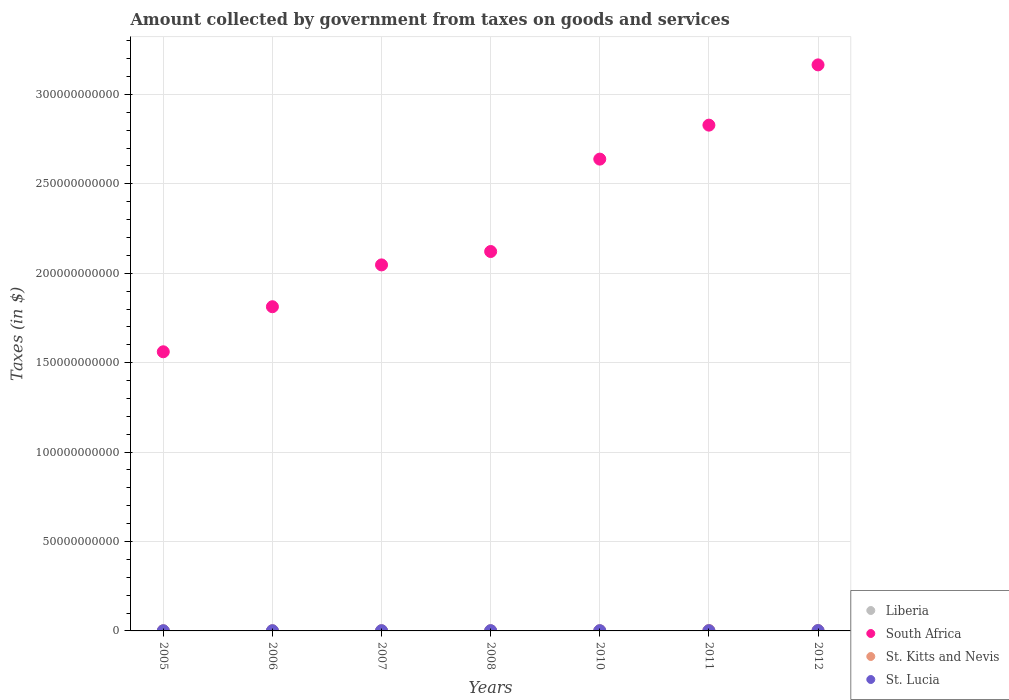How many different coloured dotlines are there?
Keep it short and to the point. 4. What is the amount collected by government from taxes on goods and services in St. Kitts and Nevis in 2007?
Provide a succinct answer. 8.41e+07. Across all years, what is the maximum amount collected by government from taxes on goods and services in St. Kitts and Nevis?
Give a very brief answer. 2.08e+08. Across all years, what is the minimum amount collected by government from taxes on goods and services in South Africa?
Give a very brief answer. 1.56e+11. What is the total amount collected by government from taxes on goods and services in St. Lucia in the graph?
Keep it short and to the point. 8.80e+08. What is the difference between the amount collected by government from taxes on goods and services in St. Lucia in 2005 and that in 2007?
Offer a very short reply. -3.02e+07. What is the difference between the amount collected by government from taxes on goods and services in South Africa in 2006 and the amount collected by government from taxes on goods and services in St. Lucia in 2008?
Keep it short and to the point. 1.81e+11. What is the average amount collected by government from taxes on goods and services in South Africa per year?
Offer a terse response. 2.31e+11. In the year 2011, what is the difference between the amount collected by government from taxes on goods and services in St. Lucia and amount collected by government from taxes on goods and services in South Africa?
Offer a very short reply. -2.83e+11. What is the ratio of the amount collected by government from taxes on goods and services in South Africa in 2008 to that in 2011?
Make the answer very short. 0.75. Is the amount collected by government from taxes on goods and services in St. Lucia in 2005 less than that in 2012?
Your answer should be compact. Yes. What is the difference between the highest and the second highest amount collected by government from taxes on goods and services in St. Lucia?
Make the answer very short. 5.04e+07. What is the difference between the highest and the lowest amount collected by government from taxes on goods and services in Liberia?
Your answer should be compact. 5.92e+05. Is the sum of the amount collected by government from taxes on goods and services in South Africa in 2006 and 2011 greater than the maximum amount collected by government from taxes on goods and services in St. Kitts and Nevis across all years?
Provide a short and direct response. Yes. Is it the case that in every year, the sum of the amount collected by government from taxes on goods and services in South Africa and amount collected by government from taxes on goods and services in Liberia  is greater than the sum of amount collected by government from taxes on goods and services in St. Kitts and Nevis and amount collected by government from taxes on goods and services in St. Lucia?
Offer a very short reply. No. Is it the case that in every year, the sum of the amount collected by government from taxes on goods and services in South Africa and amount collected by government from taxes on goods and services in St. Lucia  is greater than the amount collected by government from taxes on goods and services in Liberia?
Your response must be concise. Yes. Does the amount collected by government from taxes on goods and services in Liberia monotonically increase over the years?
Ensure brevity in your answer.  Yes. Is the amount collected by government from taxes on goods and services in St. Lucia strictly greater than the amount collected by government from taxes on goods and services in Liberia over the years?
Provide a succinct answer. Yes. What is the difference between two consecutive major ticks on the Y-axis?
Keep it short and to the point. 5.00e+1. Does the graph contain any zero values?
Ensure brevity in your answer.  No. Does the graph contain grids?
Offer a terse response. Yes. Where does the legend appear in the graph?
Offer a terse response. Bottom right. How many legend labels are there?
Offer a very short reply. 4. What is the title of the graph?
Keep it short and to the point. Amount collected by government from taxes on goods and services. Does "Slovak Republic" appear as one of the legend labels in the graph?
Ensure brevity in your answer.  No. What is the label or title of the Y-axis?
Your answer should be compact. Taxes (in $). What is the Taxes (in $) in Liberia in 2005?
Provide a short and direct response. 2.39e+05. What is the Taxes (in $) of South Africa in 2005?
Your answer should be very brief. 1.56e+11. What is the Taxes (in $) in St. Kitts and Nevis in 2005?
Your response must be concise. 6.81e+07. What is the Taxes (in $) in St. Lucia in 2005?
Keep it short and to the point. 8.95e+07. What is the Taxes (in $) of Liberia in 2006?
Give a very brief answer. 3.50e+05. What is the Taxes (in $) of South Africa in 2006?
Your response must be concise. 1.81e+11. What is the Taxes (in $) of St. Kitts and Nevis in 2006?
Your answer should be compact. 9.08e+07. What is the Taxes (in $) in St. Lucia in 2006?
Ensure brevity in your answer.  1.06e+08. What is the Taxes (in $) of Liberia in 2007?
Make the answer very short. 4.36e+05. What is the Taxes (in $) of South Africa in 2007?
Your response must be concise. 2.05e+11. What is the Taxes (in $) of St. Kitts and Nevis in 2007?
Provide a short and direct response. 8.41e+07. What is the Taxes (in $) of St. Lucia in 2007?
Make the answer very short. 1.20e+08. What is the Taxes (in $) of Liberia in 2008?
Provide a short and direct response. 4.75e+05. What is the Taxes (in $) of South Africa in 2008?
Make the answer very short. 2.12e+11. What is the Taxes (in $) in St. Kitts and Nevis in 2008?
Give a very brief answer. 8.39e+07. What is the Taxes (in $) in St. Lucia in 2008?
Make the answer very short. 1.32e+08. What is the Taxes (in $) of Liberia in 2010?
Your answer should be very brief. 6.83e+05. What is the Taxes (in $) of South Africa in 2010?
Your response must be concise. 2.64e+11. What is the Taxes (in $) of St. Kitts and Nevis in 2010?
Your response must be concise. 8.44e+07. What is the Taxes (in $) in St. Lucia in 2010?
Give a very brief answer. 1.25e+08. What is the Taxes (in $) of Liberia in 2011?
Your response must be concise. 7.33e+05. What is the Taxes (in $) in South Africa in 2011?
Offer a terse response. 2.83e+11. What is the Taxes (in $) in St. Kitts and Nevis in 2011?
Your answer should be compact. 2.08e+08. What is the Taxes (in $) in St. Lucia in 2011?
Give a very brief answer. 1.26e+08. What is the Taxes (in $) in Liberia in 2012?
Give a very brief answer. 8.31e+05. What is the Taxes (in $) of South Africa in 2012?
Provide a succinct answer. 3.17e+11. What is the Taxes (in $) in St. Kitts and Nevis in 2012?
Offer a very short reply. 2.03e+08. What is the Taxes (in $) in St. Lucia in 2012?
Make the answer very short. 1.83e+08. Across all years, what is the maximum Taxes (in $) in Liberia?
Offer a very short reply. 8.31e+05. Across all years, what is the maximum Taxes (in $) in South Africa?
Provide a succinct answer. 3.17e+11. Across all years, what is the maximum Taxes (in $) of St. Kitts and Nevis?
Make the answer very short. 2.08e+08. Across all years, what is the maximum Taxes (in $) of St. Lucia?
Keep it short and to the point. 1.83e+08. Across all years, what is the minimum Taxes (in $) of Liberia?
Your response must be concise. 2.39e+05. Across all years, what is the minimum Taxes (in $) of South Africa?
Keep it short and to the point. 1.56e+11. Across all years, what is the minimum Taxes (in $) of St. Kitts and Nevis?
Offer a very short reply. 6.81e+07. Across all years, what is the minimum Taxes (in $) of St. Lucia?
Your answer should be very brief. 8.95e+07. What is the total Taxes (in $) of Liberia in the graph?
Provide a short and direct response. 3.75e+06. What is the total Taxes (in $) in South Africa in the graph?
Offer a terse response. 1.62e+12. What is the total Taxes (in $) in St. Kitts and Nevis in the graph?
Provide a short and direct response. 8.23e+08. What is the total Taxes (in $) in St. Lucia in the graph?
Offer a terse response. 8.80e+08. What is the difference between the Taxes (in $) of Liberia in 2005 and that in 2006?
Your answer should be very brief. -1.11e+05. What is the difference between the Taxes (in $) of South Africa in 2005 and that in 2006?
Offer a terse response. -2.52e+1. What is the difference between the Taxes (in $) in St. Kitts and Nevis in 2005 and that in 2006?
Give a very brief answer. -2.27e+07. What is the difference between the Taxes (in $) in St. Lucia in 2005 and that in 2006?
Make the answer very short. -1.61e+07. What is the difference between the Taxes (in $) of Liberia in 2005 and that in 2007?
Provide a short and direct response. -1.97e+05. What is the difference between the Taxes (in $) in South Africa in 2005 and that in 2007?
Your answer should be very brief. -4.86e+1. What is the difference between the Taxes (in $) in St. Kitts and Nevis in 2005 and that in 2007?
Keep it short and to the point. -1.60e+07. What is the difference between the Taxes (in $) in St. Lucia in 2005 and that in 2007?
Offer a very short reply. -3.02e+07. What is the difference between the Taxes (in $) in Liberia in 2005 and that in 2008?
Your answer should be compact. -2.36e+05. What is the difference between the Taxes (in $) in South Africa in 2005 and that in 2008?
Give a very brief answer. -5.61e+1. What is the difference between the Taxes (in $) in St. Kitts and Nevis in 2005 and that in 2008?
Your response must be concise. -1.58e+07. What is the difference between the Taxes (in $) in St. Lucia in 2005 and that in 2008?
Provide a short and direct response. -4.27e+07. What is the difference between the Taxes (in $) of Liberia in 2005 and that in 2010?
Your answer should be very brief. -4.44e+05. What is the difference between the Taxes (in $) in South Africa in 2005 and that in 2010?
Make the answer very short. -1.08e+11. What is the difference between the Taxes (in $) in St. Kitts and Nevis in 2005 and that in 2010?
Give a very brief answer. -1.63e+07. What is the difference between the Taxes (in $) in St. Lucia in 2005 and that in 2010?
Provide a short and direct response. -3.56e+07. What is the difference between the Taxes (in $) in Liberia in 2005 and that in 2011?
Make the answer very short. -4.94e+05. What is the difference between the Taxes (in $) in South Africa in 2005 and that in 2011?
Provide a succinct answer. -1.27e+11. What is the difference between the Taxes (in $) in St. Kitts and Nevis in 2005 and that in 2011?
Your answer should be very brief. -1.40e+08. What is the difference between the Taxes (in $) of St. Lucia in 2005 and that in 2011?
Your answer should be compact. -3.62e+07. What is the difference between the Taxes (in $) of Liberia in 2005 and that in 2012?
Your answer should be very brief. -5.92e+05. What is the difference between the Taxes (in $) in South Africa in 2005 and that in 2012?
Ensure brevity in your answer.  -1.60e+11. What is the difference between the Taxes (in $) in St. Kitts and Nevis in 2005 and that in 2012?
Provide a short and direct response. -1.35e+08. What is the difference between the Taxes (in $) in St. Lucia in 2005 and that in 2012?
Provide a short and direct response. -9.31e+07. What is the difference between the Taxes (in $) in Liberia in 2006 and that in 2007?
Your answer should be very brief. -8.60e+04. What is the difference between the Taxes (in $) of South Africa in 2006 and that in 2007?
Give a very brief answer. -2.34e+1. What is the difference between the Taxes (in $) in St. Kitts and Nevis in 2006 and that in 2007?
Make the answer very short. 6.70e+06. What is the difference between the Taxes (in $) of St. Lucia in 2006 and that in 2007?
Offer a terse response. -1.41e+07. What is the difference between the Taxes (in $) in Liberia in 2006 and that in 2008?
Your answer should be very brief. -1.25e+05. What is the difference between the Taxes (in $) in South Africa in 2006 and that in 2008?
Offer a terse response. -3.09e+1. What is the difference between the Taxes (in $) of St. Kitts and Nevis in 2006 and that in 2008?
Your answer should be compact. 6.90e+06. What is the difference between the Taxes (in $) in St. Lucia in 2006 and that in 2008?
Keep it short and to the point. -2.66e+07. What is the difference between the Taxes (in $) of Liberia in 2006 and that in 2010?
Offer a very short reply. -3.32e+05. What is the difference between the Taxes (in $) of South Africa in 2006 and that in 2010?
Offer a very short reply. -8.26e+1. What is the difference between the Taxes (in $) in St. Kitts and Nevis in 2006 and that in 2010?
Your answer should be compact. 6.40e+06. What is the difference between the Taxes (in $) in St. Lucia in 2006 and that in 2010?
Provide a succinct answer. -1.95e+07. What is the difference between the Taxes (in $) of Liberia in 2006 and that in 2011?
Offer a very short reply. -3.83e+05. What is the difference between the Taxes (in $) of South Africa in 2006 and that in 2011?
Ensure brevity in your answer.  -1.02e+11. What is the difference between the Taxes (in $) of St. Kitts and Nevis in 2006 and that in 2011?
Make the answer very short. -1.18e+08. What is the difference between the Taxes (in $) of St. Lucia in 2006 and that in 2011?
Make the answer very short. -2.01e+07. What is the difference between the Taxes (in $) of Liberia in 2006 and that in 2012?
Ensure brevity in your answer.  -4.81e+05. What is the difference between the Taxes (in $) in South Africa in 2006 and that in 2012?
Make the answer very short. -1.35e+11. What is the difference between the Taxes (in $) of St. Kitts and Nevis in 2006 and that in 2012?
Provide a short and direct response. -1.12e+08. What is the difference between the Taxes (in $) in St. Lucia in 2006 and that in 2012?
Your answer should be very brief. -7.70e+07. What is the difference between the Taxes (in $) of Liberia in 2007 and that in 2008?
Provide a succinct answer. -3.91e+04. What is the difference between the Taxes (in $) of South Africa in 2007 and that in 2008?
Provide a succinct answer. -7.48e+09. What is the difference between the Taxes (in $) of St. Kitts and Nevis in 2007 and that in 2008?
Make the answer very short. 2.00e+05. What is the difference between the Taxes (in $) in St. Lucia in 2007 and that in 2008?
Your response must be concise. -1.25e+07. What is the difference between the Taxes (in $) of Liberia in 2007 and that in 2010?
Give a very brief answer. -2.46e+05. What is the difference between the Taxes (in $) of South Africa in 2007 and that in 2010?
Keep it short and to the point. -5.92e+1. What is the difference between the Taxes (in $) of St. Lucia in 2007 and that in 2010?
Offer a terse response. -5.40e+06. What is the difference between the Taxes (in $) in Liberia in 2007 and that in 2011?
Keep it short and to the point. -2.97e+05. What is the difference between the Taxes (in $) in South Africa in 2007 and that in 2011?
Your response must be concise. -7.82e+1. What is the difference between the Taxes (in $) of St. Kitts and Nevis in 2007 and that in 2011?
Offer a very short reply. -1.24e+08. What is the difference between the Taxes (in $) of St. Lucia in 2007 and that in 2011?
Give a very brief answer. -6.00e+06. What is the difference between the Taxes (in $) in Liberia in 2007 and that in 2012?
Give a very brief answer. -3.95e+05. What is the difference between the Taxes (in $) in South Africa in 2007 and that in 2012?
Offer a very short reply. -1.12e+11. What is the difference between the Taxes (in $) of St. Kitts and Nevis in 2007 and that in 2012?
Give a very brief answer. -1.19e+08. What is the difference between the Taxes (in $) in St. Lucia in 2007 and that in 2012?
Give a very brief answer. -6.29e+07. What is the difference between the Taxes (in $) of Liberia in 2008 and that in 2010?
Provide a short and direct response. -2.07e+05. What is the difference between the Taxes (in $) of South Africa in 2008 and that in 2010?
Offer a terse response. -5.17e+1. What is the difference between the Taxes (in $) of St. Kitts and Nevis in 2008 and that in 2010?
Ensure brevity in your answer.  -5.00e+05. What is the difference between the Taxes (in $) in St. Lucia in 2008 and that in 2010?
Provide a succinct answer. 7.10e+06. What is the difference between the Taxes (in $) of Liberia in 2008 and that in 2011?
Offer a very short reply. -2.58e+05. What is the difference between the Taxes (in $) in South Africa in 2008 and that in 2011?
Your answer should be very brief. -7.07e+1. What is the difference between the Taxes (in $) in St. Kitts and Nevis in 2008 and that in 2011?
Make the answer very short. -1.24e+08. What is the difference between the Taxes (in $) of St. Lucia in 2008 and that in 2011?
Offer a very short reply. 6.50e+06. What is the difference between the Taxes (in $) in Liberia in 2008 and that in 2012?
Keep it short and to the point. -3.56e+05. What is the difference between the Taxes (in $) of South Africa in 2008 and that in 2012?
Offer a very short reply. -1.04e+11. What is the difference between the Taxes (in $) in St. Kitts and Nevis in 2008 and that in 2012?
Your answer should be very brief. -1.19e+08. What is the difference between the Taxes (in $) in St. Lucia in 2008 and that in 2012?
Provide a succinct answer. -5.04e+07. What is the difference between the Taxes (in $) of Liberia in 2010 and that in 2011?
Keep it short and to the point. -5.03e+04. What is the difference between the Taxes (in $) in South Africa in 2010 and that in 2011?
Your answer should be compact. -1.90e+1. What is the difference between the Taxes (in $) in St. Kitts and Nevis in 2010 and that in 2011?
Your answer should be very brief. -1.24e+08. What is the difference between the Taxes (in $) of St. Lucia in 2010 and that in 2011?
Give a very brief answer. -6.00e+05. What is the difference between the Taxes (in $) in Liberia in 2010 and that in 2012?
Your answer should be very brief. -1.49e+05. What is the difference between the Taxes (in $) in South Africa in 2010 and that in 2012?
Give a very brief answer. -5.27e+1. What is the difference between the Taxes (in $) of St. Kitts and Nevis in 2010 and that in 2012?
Keep it short and to the point. -1.19e+08. What is the difference between the Taxes (in $) in St. Lucia in 2010 and that in 2012?
Offer a terse response. -5.75e+07. What is the difference between the Taxes (in $) of Liberia in 2011 and that in 2012?
Give a very brief answer. -9.83e+04. What is the difference between the Taxes (in $) in South Africa in 2011 and that in 2012?
Provide a short and direct response. -3.37e+1. What is the difference between the Taxes (in $) of St. Kitts and Nevis in 2011 and that in 2012?
Your response must be concise. 5.00e+06. What is the difference between the Taxes (in $) of St. Lucia in 2011 and that in 2012?
Provide a succinct answer. -5.69e+07. What is the difference between the Taxes (in $) of Liberia in 2005 and the Taxes (in $) of South Africa in 2006?
Provide a short and direct response. -1.81e+11. What is the difference between the Taxes (in $) of Liberia in 2005 and the Taxes (in $) of St. Kitts and Nevis in 2006?
Your response must be concise. -9.06e+07. What is the difference between the Taxes (in $) in Liberia in 2005 and the Taxes (in $) in St. Lucia in 2006?
Ensure brevity in your answer.  -1.05e+08. What is the difference between the Taxes (in $) of South Africa in 2005 and the Taxes (in $) of St. Kitts and Nevis in 2006?
Your answer should be very brief. 1.56e+11. What is the difference between the Taxes (in $) in South Africa in 2005 and the Taxes (in $) in St. Lucia in 2006?
Give a very brief answer. 1.56e+11. What is the difference between the Taxes (in $) of St. Kitts and Nevis in 2005 and the Taxes (in $) of St. Lucia in 2006?
Keep it short and to the point. -3.75e+07. What is the difference between the Taxes (in $) in Liberia in 2005 and the Taxes (in $) in South Africa in 2007?
Your answer should be compact. -2.05e+11. What is the difference between the Taxes (in $) of Liberia in 2005 and the Taxes (in $) of St. Kitts and Nevis in 2007?
Your response must be concise. -8.39e+07. What is the difference between the Taxes (in $) in Liberia in 2005 and the Taxes (in $) in St. Lucia in 2007?
Offer a very short reply. -1.19e+08. What is the difference between the Taxes (in $) in South Africa in 2005 and the Taxes (in $) in St. Kitts and Nevis in 2007?
Provide a short and direct response. 1.56e+11. What is the difference between the Taxes (in $) in South Africa in 2005 and the Taxes (in $) in St. Lucia in 2007?
Provide a short and direct response. 1.56e+11. What is the difference between the Taxes (in $) of St. Kitts and Nevis in 2005 and the Taxes (in $) of St. Lucia in 2007?
Give a very brief answer. -5.16e+07. What is the difference between the Taxes (in $) in Liberia in 2005 and the Taxes (in $) in South Africa in 2008?
Ensure brevity in your answer.  -2.12e+11. What is the difference between the Taxes (in $) in Liberia in 2005 and the Taxes (in $) in St. Kitts and Nevis in 2008?
Your answer should be very brief. -8.37e+07. What is the difference between the Taxes (in $) of Liberia in 2005 and the Taxes (in $) of St. Lucia in 2008?
Offer a very short reply. -1.32e+08. What is the difference between the Taxes (in $) of South Africa in 2005 and the Taxes (in $) of St. Kitts and Nevis in 2008?
Your answer should be very brief. 1.56e+11. What is the difference between the Taxes (in $) of South Africa in 2005 and the Taxes (in $) of St. Lucia in 2008?
Your answer should be very brief. 1.56e+11. What is the difference between the Taxes (in $) of St. Kitts and Nevis in 2005 and the Taxes (in $) of St. Lucia in 2008?
Your response must be concise. -6.41e+07. What is the difference between the Taxes (in $) of Liberia in 2005 and the Taxes (in $) of South Africa in 2010?
Your answer should be very brief. -2.64e+11. What is the difference between the Taxes (in $) of Liberia in 2005 and the Taxes (in $) of St. Kitts and Nevis in 2010?
Make the answer very short. -8.42e+07. What is the difference between the Taxes (in $) of Liberia in 2005 and the Taxes (in $) of St. Lucia in 2010?
Provide a succinct answer. -1.25e+08. What is the difference between the Taxes (in $) of South Africa in 2005 and the Taxes (in $) of St. Kitts and Nevis in 2010?
Your response must be concise. 1.56e+11. What is the difference between the Taxes (in $) in South Africa in 2005 and the Taxes (in $) in St. Lucia in 2010?
Provide a short and direct response. 1.56e+11. What is the difference between the Taxes (in $) in St. Kitts and Nevis in 2005 and the Taxes (in $) in St. Lucia in 2010?
Keep it short and to the point. -5.70e+07. What is the difference between the Taxes (in $) of Liberia in 2005 and the Taxes (in $) of South Africa in 2011?
Give a very brief answer. -2.83e+11. What is the difference between the Taxes (in $) in Liberia in 2005 and the Taxes (in $) in St. Kitts and Nevis in 2011?
Ensure brevity in your answer.  -2.08e+08. What is the difference between the Taxes (in $) of Liberia in 2005 and the Taxes (in $) of St. Lucia in 2011?
Your answer should be compact. -1.25e+08. What is the difference between the Taxes (in $) in South Africa in 2005 and the Taxes (in $) in St. Kitts and Nevis in 2011?
Provide a short and direct response. 1.56e+11. What is the difference between the Taxes (in $) of South Africa in 2005 and the Taxes (in $) of St. Lucia in 2011?
Your response must be concise. 1.56e+11. What is the difference between the Taxes (in $) in St. Kitts and Nevis in 2005 and the Taxes (in $) in St. Lucia in 2011?
Make the answer very short. -5.76e+07. What is the difference between the Taxes (in $) of Liberia in 2005 and the Taxes (in $) of South Africa in 2012?
Give a very brief answer. -3.17e+11. What is the difference between the Taxes (in $) in Liberia in 2005 and the Taxes (in $) in St. Kitts and Nevis in 2012?
Your answer should be very brief. -2.03e+08. What is the difference between the Taxes (in $) of Liberia in 2005 and the Taxes (in $) of St. Lucia in 2012?
Your answer should be compact. -1.82e+08. What is the difference between the Taxes (in $) of South Africa in 2005 and the Taxes (in $) of St. Kitts and Nevis in 2012?
Provide a succinct answer. 1.56e+11. What is the difference between the Taxes (in $) in South Africa in 2005 and the Taxes (in $) in St. Lucia in 2012?
Provide a succinct answer. 1.56e+11. What is the difference between the Taxes (in $) of St. Kitts and Nevis in 2005 and the Taxes (in $) of St. Lucia in 2012?
Your answer should be compact. -1.14e+08. What is the difference between the Taxes (in $) of Liberia in 2006 and the Taxes (in $) of South Africa in 2007?
Your answer should be compact. -2.05e+11. What is the difference between the Taxes (in $) of Liberia in 2006 and the Taxes (in $) of St. Kitts and Nevis in 2007?
Keep it short and to the point. -8.37e+07. What is the difference between the Taxes (in $) in Liberia in 2006 and the Taxes (in $) in St. Lucia in 2007?
Your answer should be compact. -1.19e+08. What is the difference between the Taxes (in $) in South Africa in 2006 and the Taxes (in $) in St. Kitts and Nevis in 2007?
Provide a succinct answer. 1.81e+11. What is the difference between the Taxes (in $) of South Africa in 2006 and the Taxes (in $) of St. Lucia in 2007?
Provide a short and direct response. 1.81e+11. What is the difference between the Taxes (in $) of St. Kitts and Nevis in 2006 and the Taxes (in $) of St. Lucia in 2007?
Keep it short and to the point. -2.89e+07. What is the difference between the Taxes (in $) of Liberia in 2006 and the Taxes (in $) of South Africa in 2008?
Keep it short and to the point. -2.12e+11. What is the difference between the Taxes (in $) in Liberia in 2006 and the Taxes (in $) in St. Kitts and Nevis in 2008?
Offer a very short reply. -8.35e+07. What is the difference between the Taxes (in $) in Liberia in 2006 and the Taxes (in $) in St. Lucia in 2008?
Your response must be concise. -1.32e+08. What is the difference between the Taxes (in $) of South Africa in 2006 and the Taxes (in $) of St. Kitts and Nevis in 2008?
Your response must be concise. 1.81e+11. What is the difference between the Taxes (in $) of South Africa in 2006 and the Taxes (in $) of St. Lucia in 2008?
Your answer should be very brief. 1.81e+11. What is the difference between the Taxes (in $) of St. Kitts and Nevis in 2006 and the Taxes (in $) of St. Lucia in 2008?
Your answer should be very brief. -4.14e+07. What is the difference between the Taxes (in $) in Liberia in 2006 and the Taxes (in $) in South Africa in 2010?
Provide a succinct answer. -2.64e+11. What is the difference between the Taxes (in $) of Liberia in 2006 and the Taxes (in $) of St. Kitts and Nevis in 2010?
Keep it short and to the point. -8.40e+07. What is the difference between the Taxes (in $) in Liberia in 2006 and the Taxes (in $) in St. Lucia in 2010?
Ensure brevity in your answer.  -1.25e+08. What is the difference between the Taxes (in $) in South Africa in 2006 and the Taxes (in $) in St. Kitts and Nevis in 2010?
Ensure brevity in your answer.  1.81e+11. What is the difference between the Taxes (in $) in South Africa in 2006 and the Taxes (in $) in St. Lucia in 2010?
Your answer should be very brief. 1.81e+11. What is the difference between the Taxes (in $) in St. Kitts and Nevis in 2006 and the Taxes (in $) in St. Lucia in 2010?
Keep it short and to the point. -3.43e+07. What is the difference between the Taxes (in $) in Liberia in 2006 and the Taxes (in $) in South Africa in 2011?
Offer a very short reply. -2.83e+11. What is the difference between the Taxes (in $) of Liberia in 2006 and the Taxes (in $) of St. Kitts and Nevis in 2011?
Offer a very short reply. -2.08e+08. What is the difference between the Taxes (in $) in Liberia in 2006 and the Taxes (in $) in St. Lucia in 2011?
Make the answer very short. -1.25e+08. What is the difference between the Taxes (in $) of South Africa in 2006 and the Taxes (in $) of St. Kitts and Nevis in 2011?
Make the answer very short. 1.81e+11. What is the difference between the Taxes (in $) in South Africa in 2006 and the Taxes (in $) in St. Lucia in 2011?
Your answer should be very brief. 1.81e+11. What is the difference between the Taxes (in $) in St. Kitts and Nevis in 2006 and the Taxes (in $) in St. Lucia in 2011?
Your answer should be compact. -3.49e+07. What is the difference between the Taxes (in $) in Liberia in 2006 and the Taxes (in $) in South Africa in 2012?
Provide a short and direct response. -3.17e+11. What is the difference between the Taxes (in $) in Liberia in 2006 and the Taxes (in $) in St. Kitts and Nevis in 2012?
Your response must be concise. -2.03e+08. What is the difference between the Taxes (in $) of Liberia in 2006 and the Taxes (in $) of St. Lucia in 2012?
Provide a short and direct response. -1.82e+08. What is the difference between the Taxes (in $) in South Africa in 2006 and the Taxes (in $) in St. Kitts and Nevis in 2012?
Provide a short and direct response. 1.81e+11. What is the difference between the Taxes (in $) of South Africa in 2006 and the Taxes (in $) of St. Lucia in 2012?
Offer a very short reply. 1.81e+11. What is the difference between the Taxes (in $) of St. Kitts and Nevis in 2006 and the Taxes (in $) of St. Lucia in 2012?
Your response must be concise. -9.18e+07. What is the difference between the Taxes (in $) in Liberia in 2007 and the Taxes (in $) in South Africa in 2008?
Your response must be concise. -2.12e+11. What is the difference between the Taxes (in $) of Liberia in 2007 and the Taxes (in $) of St. Kitts and Nevis in 2008?
Your answer should be compact. -8.35e+07. What is the difference between the Taxes (in $) in Liberia in 2007 and the Taxes (in $) in St. Lucia in 2008?
Provide a succinct answer. -1.32e+08. What is the difference between the Taxes (in $) of South Africa in 2007 and the Taxes (in $) of St. Kitts and Nevis in 2008?
Your answer should be very brief. 2.05e+11. What is the difference between the Taxes (in $) in South Africa in 2007 and the Taxes (in $) in St. Lucia in 2008?
Your answer should be very brief. 2.05e+11. What is the difference between the Taxes (in $) of St. Kitts and Nevis in 2007 and the Taxes (in $) of St. Lucia in 2008?
Your answer should be compact. -4.81e+07. What is the difference between the Taxes (in $) in Liberia in 2007 and the Taxes (in $) in South Africa in 2010?
Keep it short and to the point. -2.64e+11. What is the difference between the Taxes (in $) in Liberia in 2007 and the Taxes (in $) in St. Kitts and Nevis in 2010?
Ensure brevity in your answer.  -8.40e+07. What is the difference between the Taxes (in $) in Liberia in 2007 and the Taxes (in $) in St. Lucia in 2010?
Ensure brevity in your answer.  -1.25e+08. What is the difference between the Taxes (in $) of South Africa in 2007 and the Taxes (in $) of St. Kitts and Nevis in 2010?
Provide a short and direct response. 2.05e+11. What is the difference between the Taxes (in $) in South Africa in 2007 and the Taxes (in $) in St. Lucia in 2010?
Provide a short and direct response. 2.05e+11. What is the difference between the Taxes (in $) in St. Kitts and Nevis in 2007 and the Taxes (in $) in St. Lucia in 2010?
Provide a succinct answer. -4.10e+07. What is the difference between the Taxes (in $) in Liberia in 2007 and the Taxes (in $) in South Africa in 2011?
Offer a very short reply. -2.83e+11. What is the difference between the Taxes (in $) in Liberia in 2007 and the Taxes (in $) in St. Kitts and Nevis in 2011?
Ensure brevity in your answer.  -2.08e+08. What is the difference between the Taxes (in $) in Liberia in 2007 and the Taxes (in $) in St. Lucia in 2011?
Your response must be concise. -1.25e+08. What is the difference between the Taxes (in $) in South Africa in 2007 and the Taxes (in $) in St. Kitts and Nevis in 2011?
Ensure brevity in your answer.  2.04e+11. What is the difference between the Taxes (in $) in South Africa in 2007 and the Taxes (in $) in St. Lucia in 2011?
Offer a very short reply. 2.05e+11. What is the difference between the Taxes (in $) in St. Kitts and Nevis in 2007 and the Taxes (in $) in St. Lucia in 2011?
Ensure brevity in your answer.  -4.16e+07. What is the difference between the Taxes (in $) in Liberia in 2007 and the Taxes (in $) in South Africa in 2012?
Ensure brevity in your answer.  -3.17e+11. What is the difference between the Taxes (in $) in Liberia in 2007 and the Taxes (in $) in St. Kitts and Nevis in 2012?
Your response must be concise. -2.03e+08. What is the difference between the Taxes (in $) of Liberia in 2007 and the Taxes (in $) of St. Lucia in 2012?
Your response must be concise. -1.82e+08. What is the difference between the Taxes (in $) of South Africa in 2007 and the Taxes (in $) of St. Kitts and Nevis in 2012?
Make the answer very short. 2.04e+11. What is the difference between the Taxes (in $) in South Africa in 2007 and the Taxes (in $) in St. Lucia in 2012?
Your response must be concise. 2.05e+11. What is the difference between the Taxes (in $) in St. Kitts and Nevis in 2007 and the Taxes (in $) in St. Lucia in 2012?
Make the answer very short. -9.85e+07. What is the difference between the Taxes (in $) in Liberia in 2008 and the Taxes (in $) in South Africa in 2010?
Your answer should be compact. -2.64e+11. What is the difference between the Taxes (in $) in Liberia in 2008 and the Taxes (in $) in St. Kitts and Nevis in 2010?
Keep it short and to the point. -8.39e+07. What is the difference between the Taxes (in $) in Liberia in 2008 and the Taxes (in $) in St. Lucia in 2010?
Your answer should be very brief. -1.25e+08. What is the difference between the Taxes (in $) in South Africa in 2008 and the Taxes (in $) in St. Kitts and Nevis in 2010?
Give a very brief answer. 2.12e+11. What is the difference between the Taxes (in $) of South Africa in 2008 and the Taxes (in $) of St. Lucia in 2010?
Your response must be concise. 2.12e+11. What is the difference between the Taxes (in $) in St. Kitts and Nevis in 2008 and the Taxes (in $) in St. Lucia in 2010?
Your answer should be compact. -4.12e+07. What is the difference between the Taxes (in $) of Liberia in 2008 and the Taxes (in $) of South Africa in 2011?
Give a very brief answer. -2.83e+11. What is the difference between the Taxes (in $) of Liberia in 2008 and the Taxes (in $) of St. Kitts and Nevis in 2011?
Ensure brevity in your answer.  -2.08e+08. What is the difference between the Taxes (in $) of Liberia in 2008 and the Taxes (in $) of St. Lucia in 2011?
Your response must be concise. -1.25e+08. What is the difference between the Taxes (in $) of South Africa in 2008 and the Taxes (in $) of St. Kitts and Nevis in 2011?
Your answer should be very brief. 2.12e+11. What is the difference between the Taxes (in $) of South Africa in 2008 and the Taxes (in $) of St. Lucia in 2011?
Keep it short and to the point. 2.12e+11. What is the difference between the Taxes (in $) in St. Kitts and Nevis in 2008 and the Taxes (in $) in St. Lucia in 2011?
Give a very brief answer. -4.18e+07. What is the difference between the Taxes (in $) in Liberia in 2008 and the Taxes (in $) in South Africa in 2012?
Give a very brief answer. -3.17e+11. What is the difference between the Taxes (in $) of Liberia in 2008 and the Taxes (in $) of St. Kitts and Nevis in 2012?
Ensure brevity in your answer.  -2.03e+08. What is the difference between the Taxes (in $) of Liberia in 2008 and the Taxes (in $) of St. Lucia in 2012?
Offer a very short reply. -1.82e+08. What is the difference between the Taxes (in $) of South Africa in 2008 and the Taxes (in $) of St. Kitts and Nevis in 2012?
Your answer should be very brief. 2.12e+11. What is the difference between the Taxes (in $) of South Africa in 2008 and the Taxes (in $) of St. Lucia in 2012?
Offer a terse response. 2.12e+11. What is the difference between the Taxes (in $) of St. Kitts and Nevis in 2008 and the Taxes (in $) of St. Lucia in 2012?
Your answer should be compact. -9.87e+07. What is the difference between the Taxes (in $) in Liberia in 2010 and the Taxes (in $) in South Africa in 2011?
Provide a succinct answer. -2.83e+11. What is the difference between the Taxes (in $) in Liberia in 2010 and the Taxes (in $) in St. Kitts and Nevis in 2011?
Provide a short and direct response. -2.08e+08. What is the difference between the Taxes (in $) in Liberia in 2010 and the Taxes (in $) in St. Lucia in 2011?
Make the answer very short. -1.25e+08. What is the difference between the Taxes (in $) of South Africa in 2010 and the Taxes (in $) of St. Kitts and Nevis in 2011?
Ensure brevity in your answer.  2.64e+11. What is the difference between the Taxes (in $) of South Africa in 2010 and the Taxes (in $) of St. Lucia in 2011?
Offer a very short reply. 2.64e+11. What is the difference between the Taxes (in $) in St. Kitts and Nevis in 2010 and the Taxes (in $) in St. Lucia in 2011?
Ensure brevity in your answer.  -4.13e+07. What is the difference between the Taxes (in $) of Liberia in 2010 and the Taxes (in $) of South Africa in 2012?
Provide a succinct answer. -3.17e+11. What is the difference between the Taxes (in $) of Liberia in 2010 and the Taxes (in $) of St. Kitts and Nevis in 2012?
Keep it short and to the point. -2.03e+08. What is the difference between the Taxes (in $) of Liberia in 2010 and the Taxes (in $) of St. Lucia in 2012?
Provide a succinct answer. -1.82e+08. What is the difference between the Taxes (in $) in South Africa in 2010 and the Taxes (in $) in St. Kitts and Nevis in 2012?
Offer a terse response. 2.64e+11. What is the difference between the Taxes (in $) in South Africa in 2010 and the Taxes (in $) in St. Lucia in 2012?
Your answer should be very brief. 2.64e+11. What is the difference between the Taxes (in $) in St. Kitts and Nevis in 2010 and the Taxes (in $) in St. Lucia in 2012?
Keep it short and to the point. -9.82e+07. What is the difference between the Taxes (in $) in Liberia in 2011 and the Taxes (in $) in South Africa in 2012?
Your answer should be compact. -3.17e+11. What is the difference between the Taxes (in $) of Liberia in 2011 and the Taxes (in $) of St. Kitts and Nevis in 2012?
Your response must be concise. -2.03e+08. What is the difference between the Taxes (in $) in Liberia in 2011 and the Taxes (in $) in St. Lucia in 2012?
Give a very brief answer. -1.82e+08. What is the difference between the Taxes (in $) of South Africa in 2011 and the Taxes (in $) of St. Kitts and Nevis in 2012?
Make the answer very short. 2.83e+11. What is the difference between the Taxes (in $) in South Africa in 2011 and the Taxes (in $) in St. Lucia in 2012?
Keep it short and to the point. 2.83e+11. What is the difference between the Taxes (in $) of St. Kitts and Nevis in 2011 and the Taxes (in $) of St. Lucia in 2012?
Offer a terse response. 2.57e+07. What is the average Taxes (in $) in Liberia per year?
Ensure brevity in your answer.  5.35e+05. What is the average Taxes (in $) of South Africa per year?
Give a very brief answer. 2.31e+11. What is the average Taxes (in $) of St. Kitts and Nevis per year?
Your response must be concise. 1.18e+08. What is the average Taxes (in $) of St. Lucia per year?
Offer a very short reply. 1.26e+08. In the year 2005, what is the difference between the Taxes (in $) in Liberia and Taxes (in $) in South Africa?
Your response must be concise. -1.56e+11. In the year 2005, what is the difference between the Taxes (in $) of Liberia and Taxes (in $) of St. Kitts and Nevis?
Your answer should be compact. -6.79e+07. In the year 2005, what is the difference between the Taxes (in $) of Liberia and Taxes (in $) of St. Lucia?
Keep it short and to the point. -8.93e+07. In the year 2005, what is the difference between the Taxes (in $) of South Africa and Taxes (in $) of St. Kitts and Nevis?
Provide a short and direct response. 1.56e+11. In the year 2005, what is the difference between the Taxes (in $) of South Africa and Taxes (in $) of St. Lucia?
Your answer should be very brief. 1.56e+11. In the year 2005, what is the difference between the Taxes (in $) in St. Kitts and Nevis and Taxes (in $) in St. Lucia?
Your response must be concise. -2.14e+07. In the year 2006, what is the difference between the Taxes (in $) in Liberia and Taxes (in $) in South Africa?
Provide a succinct answer. -1.81e+11. In the year 2006, what is the difference between the Taxes (in $) of Liberia and Taxes (in $) of St. Kitts and Nevis?
Offer a terse response. -9.04e+07. In the year 2006, what is the difference between the Taxes (in $) of Liberia and Taxes (in $) of St. Lucia?
Provide a short and direct response. -1.05e+08. In the year 2006, what is the difference between the Taxes (in $) of South Africa and Taxes (in $) of St. Kitts and Nevis?
Your answer should be very brief. 1.81e+11. In the year 2006, what is the difference between the Taxes (in $) in South Africa and Taxes (in $) in St. Lucia?
Your response must be concise. 1.81e+11. In the year 2006, what is the difference between the Taxes (in $) in St. Kitts and Nevis and Taxes (in $) in St. Lucia?
Make the answer very short. -1.48e+07. In the year 2007, what is the difference between the Taxes (in $) of Liberia and Taxes (in $) of South Africa?
Provide a succinct answer. -2.05e+11. In the year 2007, what is the difference between the Taxes (in $) in Liberia and Taxes (in $) in St. Kitts and Nevis?
Offer a terse response. -8.37e+07. In the year 2007, what is the difference between the Taxes (in $) in Liberia and Taxes (in $) in St. Lucia?
Keep it short and to the point. -1.19e+08. In the year 2007, what is the difference between the Taxes (in $) in South Africa and Taxes (in $) in St. Kitts and Nevis?
Your response must be concise. 2.05e+11. In the year 2007, what is the difference between the Taxes (in $) in South Africa and Taxes (in $) in St. Lucia?
Your answer should be compact. 2.05e+11. In the year 2007, what is the difference between the Taxes (in $) of St. Kitts and Nevis and Taxes (in $) of St. Lucia?
Make the answer very short. -3.56e+07. In the year 2008, what is the difference between the Taxes (in $) of Liberia and Taxes (in $) of South Africa?
Provide a succinct answer. -2.12e+11. In the year 2008, what is the difference between the Taxes (in $) in Liberia and Taxes (in $) in St. Kitts and Nevis?
Give a very brief answer. -8.34e+07. In the year 2008, what is the difference between the Taxes (in $) of Liberia and Taxes (in $) of St. Lucia?
Provide a succinct answer. -1.32e+08. In the year 2008, what is the difference between the Taxes (in $) in South Africa and Taxes (in $) in St. Kitts and Nevis?
Your answer should be compact. 2.12e+11. In the year 2008, what is the difference between the Taxes (in $) in South Africa and Taxes (in $) in St. Lucia?
Your answer should be very brief. 2.12e+11. In the year 2008, what is the difference between the Taxes (in $) of St. Kitts and Nevis and Taxes (in $) of St. Lucia?
Make the answer very short. -4.83e+07. In the year 2010, what is the difference between the Taxes (in $) in Liberia and Taxes (in $) in South Africa?
Your answer should be compact. -2.64e+11. In the year 2010, what is the difference between the Taxes (in $) in Liberia and Taxes (in $) in St. Kitts and Nevis?
Your answer should be very brief. -8.37e+07. In the year 2010, what is the difference between the Taxes (in $) in Liberia and Taxes (in $) in St. Lucia?
Your answer should be very brief. -1.24e+08. In the year 2010, what is the difference between the Taxes (in $) in South Africa and Taxes (in $) in St. Kitts and Nevis?
Your answer should be compact. 2.64e+11. In the year 2010, what is the difference between the Taxes (in $) in South Africa and Taxes (in $) in St. Lucia?
Your answer should be very brief. 2.64e+11. In the year 2010, what is the difference between the Taxes (in $) of St. Kitts and Nevis and Taxes (in $) of St. Lucia?
Your response must be concise. -4.07e+07. In the year 2011, what is the difference between the Taxes (in $) of Liberia and Taxes (in $) of South Africa?
Provide a short and direct response. -2.83e+11. In the year 2011, what is the difference between the Taxes (in $) in Liberia and Taxes (in $) in St. Kitts and Nevis?
Offer a terse response. -2.08e+08. In the year 2011, what is the difference between the Taxes (in $) of Liberia and Taxes (in $) of St. Lucia?
Provide a succinct answer. -1.25e+08. In the year 2011, what is the difference between the Taxes (in $) in South Africa and Taxes (in $) in St. Kitts and Nevis?
Offer a very short reply. 2.83e+11. In the year 2011, what is the difference between the Taxes (in $) in South Africa and Taxes (in $) in St. Lucia?
Your answer should be compact. 2.83e+11. In the year 2011, what is the difference between the Taxes (in $) in St. Kitts and Nevis and Taxes (in $) in St. Lucia?
Your answer should be compact. 8.26e+07. In the year 2012, what is the difference between the Taxes (in $) of Liberia and Taxes (in $) of South Africa?
Give a very brief answer. -3.17e+11. In the year 2012, what is the difference between the Taxes (in $) in Liberia and Taxes (in $) in St. Kitts and Nevis?
Your response must be concise. -2.02e+08. In the year 2012, what is the difference between the Taxes (in $) of Liberia and Taxes (in $) of St. Lucia?
Provide a succinct answer. -1.82e+08. In the year 2012, what is the difference between the Taxes (in $) in South Africa and Taxes (in $) in St. Kitts and Nevis?
Give a very brief answer. 3.16e+11. In the year 2012, what is the difference between the Taxes (in $) in South Africa and Taxes (in $) in St. Lucia?
Your response must be concise. 3.16e+11. In the year 2012, what is the difference between the Taxes (in $) in St. Kitts and Nevis and Taxes (in $) in St. Lucia?
Give a very brief answer. 2.07e+07. What is the ratio of the Taxes (in $) of Liberia in 2005 to that in 2006?
Offer a very short reply. 0.68. What is the ratio of the Taxes (in $) of South Africa in 2005 to that in 2006?
Keep it short and to the point. 0.86. What is the ratio of the Taxes (in $) in St. Lucia in 2005 to that in 2006?
Your response must be concise. 0.85. What is the ratio of the Taxes (in $) of Liberia in 2005 to that in 2007?
Give a very brief answer. 0.55. What is the ratio of the Taxes (in $) of South Africa in 2005 to that in 2007?
Offer a terse response. 0.76. What is the ratio of the Taxes (in $) of St. Kitts and Nevis in 2005 to that in 2007?
Provide a succinct answer. 0.81. What is the ratio of the Taxes (in $) of St. Lucia in 2005 to that in 2007?
Provide a short and direct response. 0.75. What is the ratio of the Taxes (in $) of Liberia in 2005 to that in 2008?
Your response must be concise. 0.5. What is the ratio of the Taxes (in $) in South Africa in 2005 to that in 2008?
Keep it short and to the point. 0.74. What is the ratio of the Taxes (in $) in St. Kitts and Nevis in 2005 to that in 2008?
Give a very brief answer. 0.81. What is the ratio of the Taxes (in $) of St. Lucia in 2005 to that in 2008?
Your response must be concise. 0.68. What is the ratio of the Taxes (in $) of Liberia in 2005 to that in 2010?
Keep it short and to the point. 0.35. What is the ratio of the Taxes (in $) of South Africa in 2005 to that in 2010?
Your response must be concise. 0.59. What is the ratio of the Taxes (in $) of St. Kitts and Nevis in 2005 to that in 2010?
Offer a very short reply. 0.81. What is the ratio of the Taxes (in $) of St. Lucia in 2005 to that in 2010?
Your answer should be very brief. 0.72. What is the ratio of the Taxes (in $) in Liberia in 2005 to that in 2011?
Provide a short and direct response. 0.33. What is the ratio of the Taxes (in $) of South Africa in 2005 to that in 2011?
Your response must be concise. 0.55. What is the ratio of the Taxes (in $) in St. Kitts and Nevis in 2005 to that in 2011?
Ensure brevity in your answer.  0.33. What is the ratio of the Taxes (in $) in St. Lucia in 2005 to that in 2011?
Offer a very short reply. 0.71. What is the ratio of the Taxes (in $) in Liberia in 2005 to that in 2012?
Make the answer very short. 0.29. What is the ratio of the Taxes (in $) of South Africa in 2005 to that in 2012?
Provide a succinct answer. 0.49. What is the ratio of the Taxes (in $) of St. Kitts and Nevis in 2005 to that in 2012?
Provide a succinct answer. 0.34. What is the ratio of the Taxes (in $) of St. Lucia in 2005 to that in 2012?
Ensure brevity in your answer.  0.49. What is the ratio of the Taxes (in $) of Liberia in 2006 to that in 2007?
Make the answer very short. 0.8. What is the ratio of the Taxes (in $) in South Africa in 2006 to that in 2007?
Make the answer very short. 0.89. What is the ratio of the Taxes (in $) of St. Kitts and Nevis in 2006 to that in 2007?
Your answer should be very brief. 1.08. What is the ratio of the Taxes (in $) of St. Lucia in 2006 to that in 2007?
Your response must be concise. 0.88. What is the ratio of the Taxes (in $) in Liberia in 2006 to that in 2008?
Ensure brevity in your answer.  0.74. What is the ratio of the Taxes (in $) of South Africa in 2006 to that in 2008?
Give a very brief answer. 0.85. What is the ratio of the Taxes (in $) of St. Kitts and Nevis in 2006 to that in 2008?
Your answer should be very brief. 1.08. What is the ratio of the Taxes (in $) of St. Lucia in 2006 to that in 2008?
Offer a terse response. 0.8. What is the ratio of the Taxes (in $) of Liberia in 2006 to that in 2010?
Ensure brevity in your answer.  0.51. What is the ratio of the Taxes (in $) of South Africa in 2006 to that in 2010?
Ensure brevity in your answer.  0.69. What is the ratio of the Taxes (in $) of St. Kitts and Nevis in 2006 to that in 2010?
Give a very brief answer. 1.08. What is the ratio of the Taxes (in $) in St. Lucia in 2006 to that in 2010?
Your answer should be very brief. 0.84. What is the ratio of the Taxes (in $) in Liberia in 2006 to that in 2011?
Provide a short and direct response. 0.48. What is the ratio of the Taxes (in $) of South Africa in 2006 to that in 2011?
Offer a very short reply. 0.64. What is the ratio of the Taxes (in $) of St. Kitts and Nevis in 2006 to that in 2011?
Offer a terse response. 0.44. What is the ratio of the Taxes (in $) in St. Lucia in 2006 to that in 2011?
Provide a succinct answer. 0.84. What is the ratio of the Taxes (in $) of Liberia in 2006 to that in 2012?
Ensure brevity in your answer.  0.42. What is the ratio of the Taxes (in $) of South Africa in 2006 to that in 2012?
Your response must be concise. 0.57. What is the ratio of the Taxes (in $) of St. Kitts and Nevis in 2006 to that in 2012?
Offer a terse response. 0.45. What is the ratio of the Taxes (in $) of St. Lucia in 2006 to that in 2012?
Provide a succinct answer. 0.58. What is the ratio of the Taxes (in $) of Liberia in 2007 to that in 2008?
Keep it short and to the point. 0.92. What is the ratio of the Taxes (in $) in South Africa in 2007 to that in 2008?
Ensure brevity in your answer.  0.96. What is the ratio of the Taxes (in $) in St. Kitts and Nevis in 2007 to that in 2008?
Provide a succinct answer. 1. What is the ratio of the Taxes (in $) of St. Lucia in 2007 to that in 2008?
Make the answer very short. 0.91. What is the ratio of the Taxes (in $) in Liberia in 2007 to that in 2010?
Offer a terse response. 0.64. What is the ratio of the Taxes (in $) of South Africa in 2007 to that in 2010?
Your answer should be very brief. 0.78. What is the ratio of the Taxes (in $) of St. Kitts and Nevis in 2007 to that in 2010?
Offer a very short reply. 1. What is the ratio of the Taxes (in $) of St. Lucia in 2007 to that in 2010?
Provide a succinct answer. 0.96. What is the ratio of the Taxes (in $) of Liberia in 2007 to that in 2011?
Provide a short and direct response. 0.6. What is the ratio of the Taxes (in $) in South Africa in 2007 to that in 2011?
Provide a short and direct response. 0.72. What is the ratio of the Taxes (in $) in St. Kitts and Nevis in 2007 to that in 2011?
Offer a very short reply. 0.4. What is the ratio of the Taxes (in $) of St. Lucia in 2007 to that in 2011?
Keep it short and to the point. 0.95. What is the ratio of the Taxes (in $) in Liberia in 2007 to that in 2012?
Your answer should be compact. 0.52. What is the ratio of the Taxes (in $) in South Africa in 2007 to that in 2012?
Offer a terse response. 0.65. What is the ratio of the Taxes (in $) in St. Kitts and Nevis in 2007 to that in 2012?
Keep it short and to the point. 0.41. What is the ratio of the Taxes (in $) in St. Lucia in 2007 to that in 2012?
Your answer should be compact. 0.66. What is the ratio of the Taxes (in $) in Liberia in 2008 to that in 2010?
Your answer should be compact. 0.7. What is the ratio of the Taxes (in $) in South Africa in 2008 to that in 2010?
Your response must be concise. 0.8. What is the ratio of the Taxes (in $) in St. Lucia in 2008 to that in 2010?
Offer a very short reply. 1.06. What is the ratio of the Taxes (in $) in Liberia in 2008 to that in 2011?
Keep it short and to the point. 0.65. What is the ratio of the Taxes (in $) in South Africa in 2008 to that in 2011?
Provide a succinct answer. 0.75. What is the ratio of the Taxes (in $) in St. Kitts and Nevis in 2008 to that in 2011?
Give a very brief answer. 0.4. What is the ratio of the Taxes (in $) in St. Lucia in 2008 to that in 2011?
Provide a succinct answer. 1.05. What is the ratio of the Taxes (in $) in Liberia in 2008 to that in 2012?
Provide a succinct answer. 0.57. What is the ratio of the Taxes (in $) of South Africa in 2008 to that in 2012?
Offer a terse response. 0.67. What is the ratio of the Taxes (in $) of St. Kitts and Nevis in 2008 to that in 2012?
Ensure brevity in your answer.  0.41. What is the ratio of the Taxes (in $) in St. Lucia in 2008 to that in 2012?
Keep it short and to the point. 0.72. What is the ratio of the Taxes (in $) in Liberia in 2010 to that in 2011?
Provide a succinct answer. 0.93. What is the ratio of the Taxes (in $) of South Africa in 2010 to that in 2011?
Give a very brief answer. 0.93. What is the ratio of the Taxes (in $) of St. Kitts and Nevis in 2010 to that in 2011?
Provide a succinct answer. 0.41. What is the ratio of the Taxes (in $) of Liberia in 2010 to that in 2012?
Keep it short and to the point. 0.82. What is the ratio of the Taxes (in $) in South Africa in 2010 to that in 2012?
Ensure brevity in your answer.  0.83. What is the ratio of the Taxes (in $) in St. Kitts and Nevis in 2010 to that in 2012?
Ensure brevity in your answer.  0.42. What is the ratio of the Taxes (in $) in St. Lucia in 2010 to that in 2012?
Offer a very short reply. 0.69. What is the ratio of the Taxes (in $) of Liberia in 2011 to that in 2012?
Your answer should be compact. 0.88. What is the ratio of the Taxes (in $) in South Africa in 2011 to that in 2012?
Offer a terse response. 0.89. What is the ratio of the Taxes (in $) in St. Kitts and Nevis in 2011 to that in 2012?
Keep it short and to the point. 1.02. What is the ratio of the Taxes (in $) of St. Lucia in 2011 to that in 2012?
Provide a short and direct response. 0.69. What is the difference between the highest and the second highest Taxes (in $) of Liberia?
Make the answer very short. 9.83e+04. What is the difference between the highest and the second highest Taxes (in $) in South Africa?
Keep it short and to the point. 3.37e+1. What is the difference between the highest and the second highest Taxes (in $) in St. Lucia?
Offer a very short reply. 5.04e+07. What is the difference between the highest and the lowest Taxes (in $) of Liberia?
Keep it short and to the point. 5.92e+05. What is the difference between the highest and the lowest Taxes (in $) in South Africa?
Offer a very short reply. 1.60e+11. What is the difference between the highest and the lowest Taxes (in $) of St. Kitts and Nevis?
Your answer should be compact. 1.40e+08. What is the difference between the highest and the lowest Taxes (in $) of St. Lucia?
Offer a terse response. 9.31e+07. 